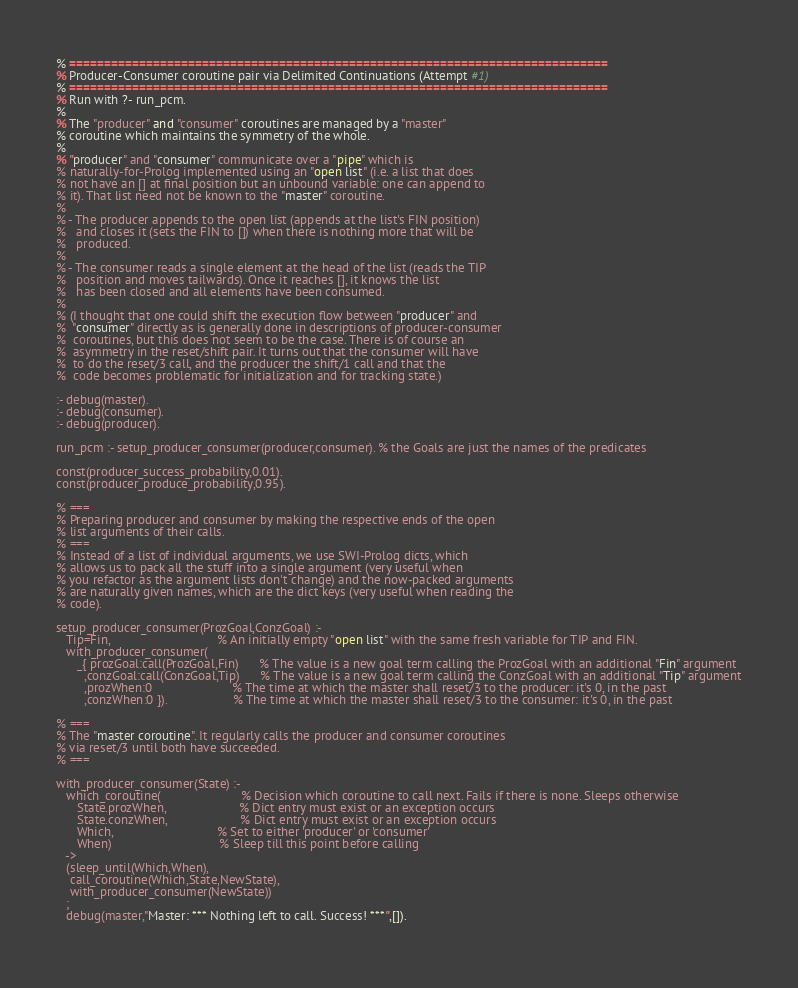<code> <loc_0><loc_0><loc_500><loc_500><_Perl_>% =============================================================================
% Producer-Consumer coroutine pair via Delimited Continuations (Attempt #1)
% =============================================================================
% Run with ?- run_pcm.
%
% The "producer" and "consumer" coroutines are managed by a "master" 
% coroutine which maintains the symmetry of the whole.
%
% "producer" and "consumer" communicate over a "pipe" which is
% naturally-for-Prolog implemented using an "open list" (i.e. a list that does 
% not have an [] at final position but an unbound variable: one can append to
% it). That list need not be known to the "master" coroutine.
% 
% - The producer appends to the open list (appends at the list's FIN position)
%   and closes it (sets the FIN to []) when there is nothing more that will be
%   produced.
%
% - The consumer reads a single element at the head of the list (reads the TIP
%   position and moves tailwards). Once it reaches [], it knows the list 
%   has been closed and all elements have been consumed.
%
% (I thought that one could shift the execution flow between "producer" and 
%  "consumer" directly as is generally done in descriptions of producer-consumer
%  coroutines, but this does not seem to be the case. There is of course an 
%  asymmetry in the reset/shift pair. It turns out that the consumer will have
%  to do the reset/3 call, and the producer the shift/1 call and that the
%  code becomes problematic for initialization and for tracking state.)

:- debug(master).
:- debug(consumer).
:- debug(producer).

run_pcm :- setup_producer_consumer(producer,consumer). % the Goals are just the names of the predicates

const(producer_success_probability,0.01).
const(producer_produce_probability,0.95).

% ===
% Preparing producer and consumer by making the respective ends of the open
% list arguments of their calls.
% ===
% Instead of a list of individual arguments, we use SWI-Prolog dicts, which
% allows us to pack all the stuff into a single argument (very useful when
% you refactor as the argument lists don't change) and the now-packed arguments
% are naturally given names, which are the dict keys (very useful when reading the
% code).
   
setup_producer_consumer(ProzGoal,ConzGoal) :-
   Tip=Fin,                               % An initially empty "open list" with the same fresh variable for TIP and FIN.
   with_producer_consumer(
      _{ prozGoal:call(ProzGoal,Fin)      % The value is a new goal term calling the ProzGoal with an additional "Fin" argument
        ,conzGoal:call(ConzGoal,Tip)      % The value is a new goal term calling the ConzGoal with an additional "Tip" argument
        ,prozWhen:0                       % The time at which the master shall reset/3 to the producer: it's 0, in the past
        ,conzWhen:0 }).                   % The time at which the master shall reset/3 to the consumer: it's 0, in the past 

% ===
% The "master coroutine". It regularly calls the producer and consumer coroutines 
% via reset/3 until both have succeeded.
% ===

with_producer_consumer(State) :-
   which_coroutine(                       % Decision which coroutine to call next. Fails if there is none. Sleeps otherwise
      State.prozWhen,                     % Dict entry must exist or an exception occurs
      State.conzWhen,                     % Dict entry must exist or an exception occurs
      Which,                              % Set to either 'producer' or 'consumer'
      When)                               % Sleep till this point before calling
   ->  
   (sleep_until(Which,When),
    call_coroutine(Which,State,NewState),
    with_producer_consumer(NewState))
   ;
   debug(master,"Master: *** Nothing left to call. Success! ***",[]).
                                   </code> 